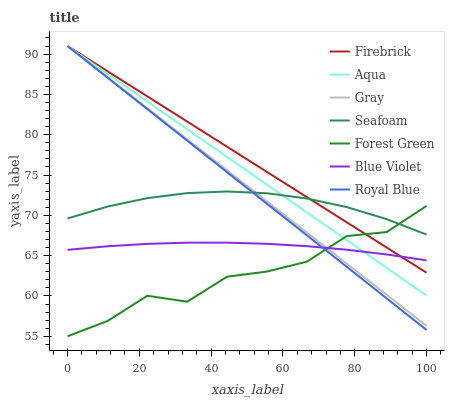Does Forest Green have the minimum area under the curve?
Answer yes or no. Yes. Does Firebrick have the maximum area under the curve?
Answer yes or no. Yes. Does Aqua have the minimum area under the curve?
Answer yes or no. No. Does Aqua have the maximum area under the curve?
Answer yes or no. No. Is Aqua the smoothest?
Answer yes or no. Yes. Is Forest Green the roughest?
Answer yes or no. Yes. Is Firebrick the smoothest?
Answer yes or no. No. Is Firebrick the roughest?
Answer yes or no. No. Does Forest Green have the lowest value?
Answer yes or no. Yes. Does Firebrick have the lowest value?
Answer yes or no. No. Does Royal Blue have the highest value?
Answer yes or no. Yes. Does Seafoam have the highest value?
Answer yes or no. No. Is Blue Violet less than Seafoam?
Answer yes or no. Yes. Is Seafoam greater than Blue Violet?
Answer yes or no. Yes. Does Blue Violet intersect Forest Green?
Answer yes or no. Yes. Is Blue Violet less than Forest Green?
Answer yes or no. No. Is Blue Violet greater than Forest Green?
Answer yes or no. No. Does Blue Violet intersect Seafoam?
Answer yes or no. No. 